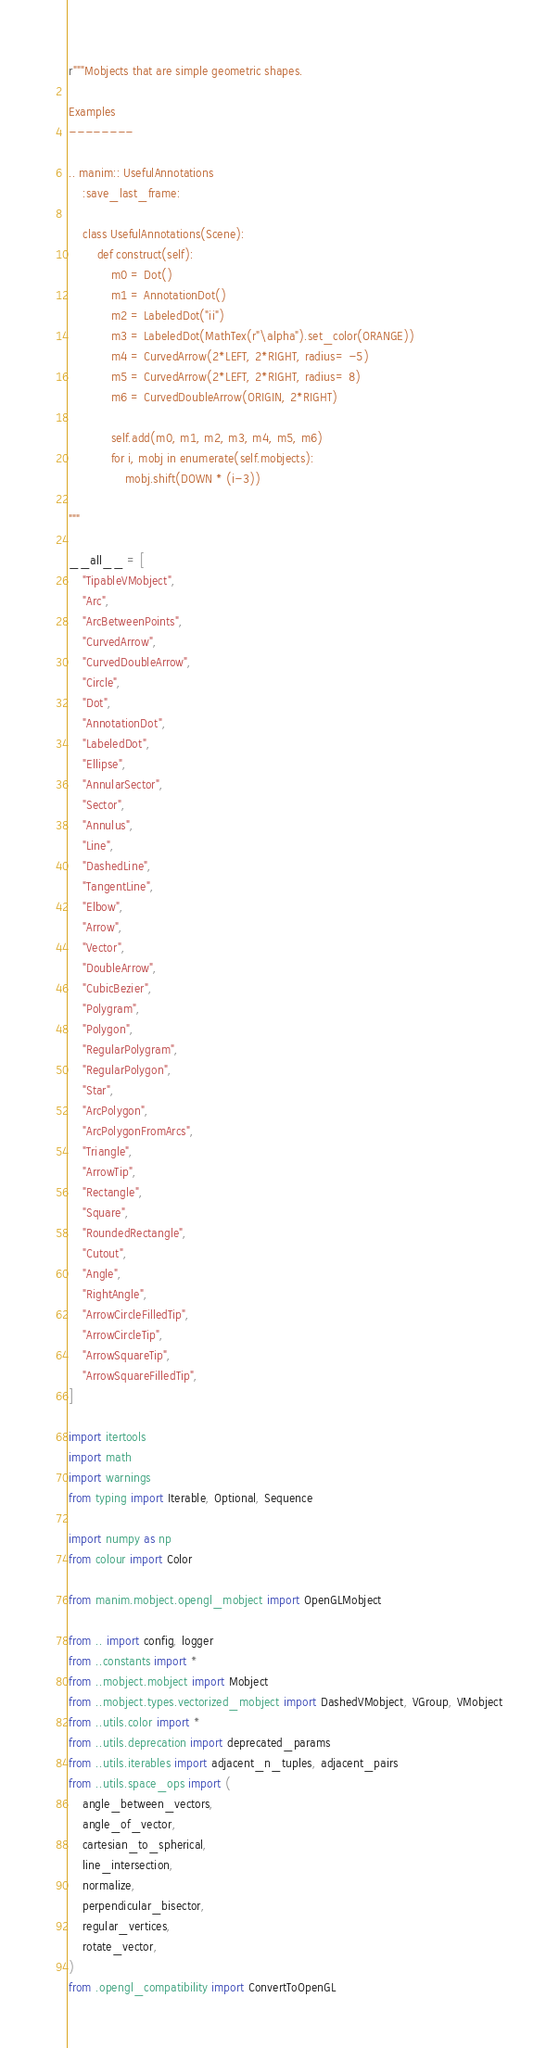<code> <loc_0><loc_0><loc_500><loc_500><_Python_>r"""Mobjects that are simple geometric shapes.

Examples
--------

.. manim:: UsefulAnnotations
    :save_last_frame:

    class UsefulAnnotations(Scene):
        def construct(self):
            m0 = Dot()
            m1 = AnnotationDot()
            m2 = LabeledDot("ii")
            m3 = LabeledDot(MathTex(r"\alpha").set_color(ORANGE))
            m4 = CurvedArrow(2*LEFT, 2*RIGHT, radius= -5)
            m5 = CurvedArrow(2*LEFT, 2*RIGHT, radius= 8)
            m6 = CurvedDoubleArrow(ORIGIN, 2*RIGHT)

            self.add(m0, m1, m2, m3, m4, m5, m6)
            for i, mobj in enumerate(self.mobjects):
                mobj.shift(DOWN * (i-3))

"""

__all__ = [
    "TipableVMobject",
    "Arc",
    "ArcBetweenPoints",
    "CurvedArrow",
    "CurvedDoubleArrow",
    "Circle",
    "Dot",
    "AnnotationDot",
    "LabeledDot",
    "Ellipse",
    "AnnularSector",
    "Sector",
    "Annulus",
    "Line",
    "DashedLine",
    "TangentLine",
    "Elbow",
    "Arrow",
    "Vector",
    "DoubleArrow",
    "CubicBezier",
    "Polygram",
    "Polygon",
    "RegularPolygram",
    "RegularPolygon",
    "Star",
    "ArcPolygon",
    "ArcPolygonFromArcs",
    "Triangle",
    "ArrowTip",
    "Rectangle",
    "Square",
    "RoundedRectangle",
    "Cutout",
    "Angle",
    "RightAngle",
    "ArrowCircleFilledTip",
    "ArrowCircleTip",
    "ArrowSquareTip",
    "ArrowSquareFilledTip",
]

import itertools
import math
import warnings
from typing import Iterable, Optional, Sequence

import numpy as np
from colour import Color

from manim.mobject.opengl_mobject import OpenGLMobject

from .. import config, logger
from ..constants import *
from ..mobject.mobject import Mobject
from ..mobject.types.vectorized_mobject import DashedVMobject, VGroup, VMobject
from ..utils.color import *
from ..utils.deprecation import deprecated_params
from ..utils.iterables import adjacent_n_tuples, adjacent_pairs
from ..utils.space_ops import (
    angle_between_vectors,
    angle_of_vector,
    cartesian_to_spherical,
    line_intersection,
    normalize,
    perpendicular_bisector,
    regular_vertices,
    rotate_vector,
)
from .opengl_compatibility import ConvertToOpenGL

</code> 